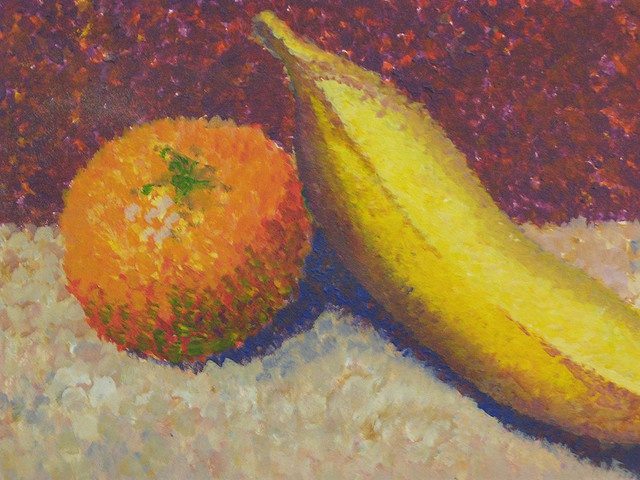Describe the objects in this image and their specific colors. I can see banana in purple, gold, olive, and khaki tones and orange in purple, orange, brown, and olive tones in this image. 